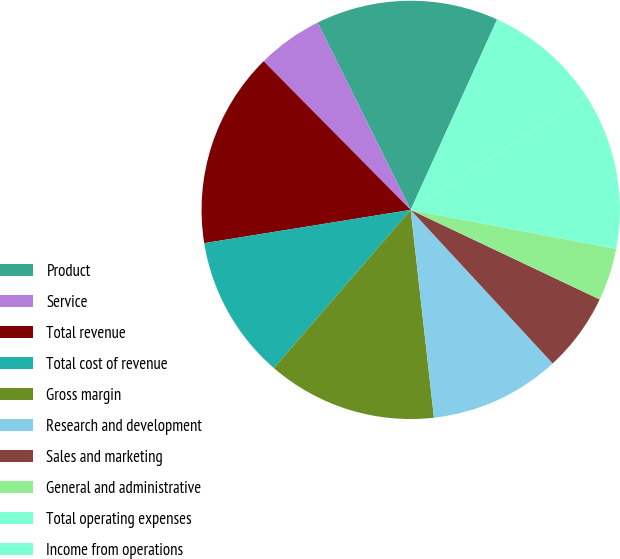<chart> <loc_0><loc_0><loc_500><loc_500><pie_chart><fcel>Product<fcel>Service<fcel>Total revenue<fcel>Total cost of revenue<fcel>Gross margin<fcel>Research and development<fcel>Sales and marketing<fcel>General and administrative<fcel>Total operating expenses<fcel>Income from operations<nl><fcel>14.12%<fcel>5.07%<fcel>15.13%<fcel>11.11%<fcel>13.12%<fcel>10.1%<fcel>6.08%<fcel>4.06%<fcel>12.11%<fcel>9.09%<nl></chart> 